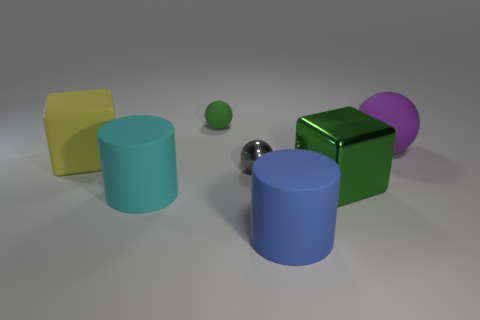Add 3 purple things. How many objects exist? 10 Subtract all blocks. How many objects are left? 5 Subtract all large purple blocks. Subtract all cyan things. How many objects are left? 6 Add 3 cyan matte cylinders. How many cyan matte cylinders are left? 4 Add 1 brown shiny cylinders. How many brown shiny cylinders exist? 1 Subtract 1 gray spheres. How many objects are left? 6 